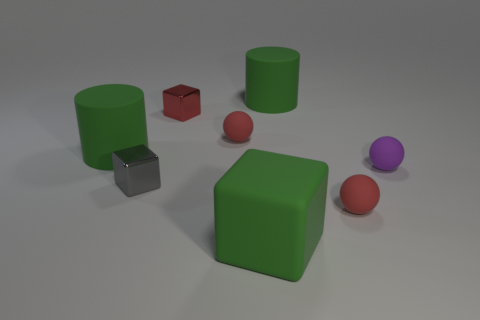Subtract all big green rubber cubes. How many cubes are left? 2 Subtract all gray cubes. How many cubes are left? 2 Subtract 1 blocks. How many blocks are left? 2 Add 4 tiny shiny cubes. How many tiny shiny cubes exist? 6 Add 1 tiny metal cubes. How many objects exist? 9 Subtract 0 blue blocks. How many objects are left? 8 Subtract all cylinders. How many objects are left? 6 Subtract all brown cylinders. Subtract all blue balls. How many cylinders are left? 2 Subtract all yellow balls. How many cyan blocks are left? 0 Subtract all red metal objects. Subtract all small red things. How many objects are left? 4 